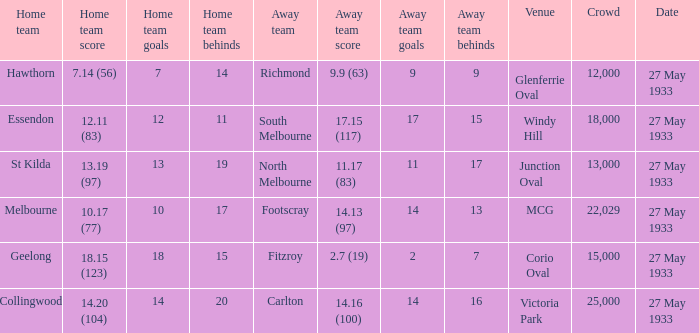During st kilda's home game, what was the number of people in the crowd? 13000.0. 